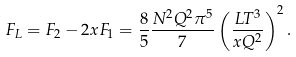Convert formula to latex. <formula><loc_0><loc_0><loc_500><loc_500>F _ { L } = F _ { 2 } - 2 x F _ { 1 } = \frac { 8 } { 5 } \frac { N ^ { 2 } Q ^ { 2 } \pi ^ { 5 } } { 7 } \left ( \frac { L T ^ { 3 } } { x Q ^ { 2 } } \right ) ^ { 2 } .</formula> 